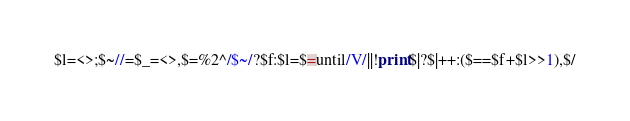Convert code to text. <code><loc_0><loc_0><loc_500><loc_500><_Perl_>$l=<>;$~//=$_=<>,$=%2^/$~/?$f:$l=$=until/V/||!print$|?$|++:($==$f+$l>>1),$/</code> 